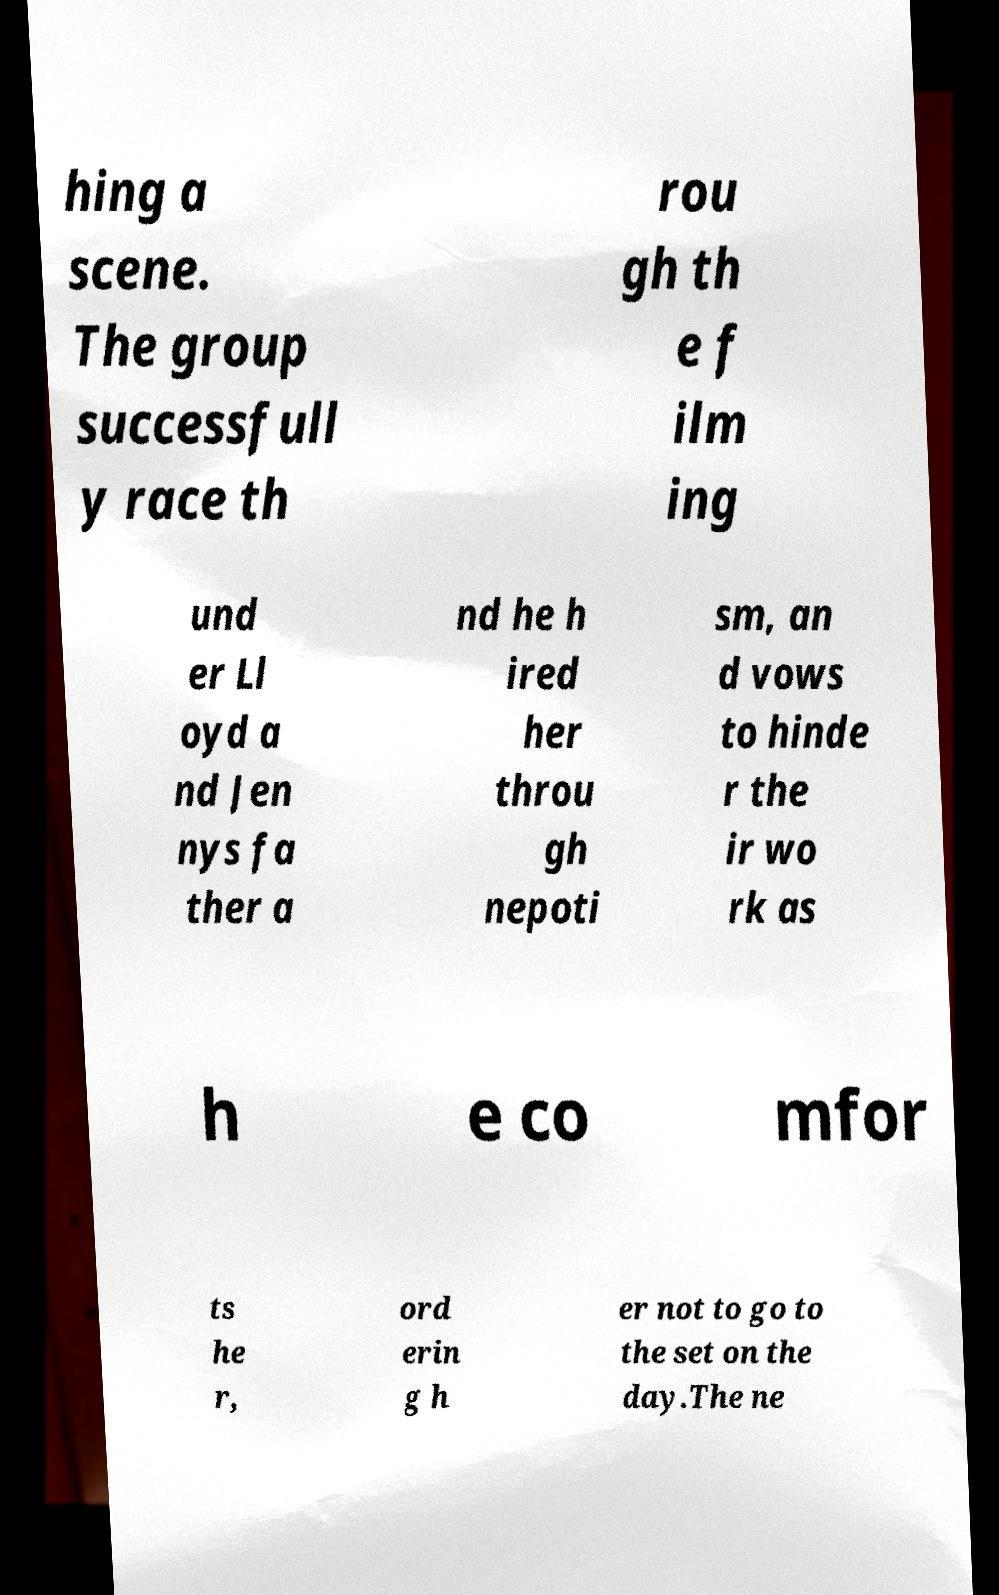There's text embedded in this image that I need extracted. Can you transcribe it verbatim? hing a scene. The group successfull y race th rou gh th e f ilm ing und er Ll oyd a nd Jen nys fa ther a nd he h ired her throu gh nepoti sm, an d vows to hinde r the ir wo rk as h e co mfor ts he r, ord erin g h er not to go to the set on the day.The ne 